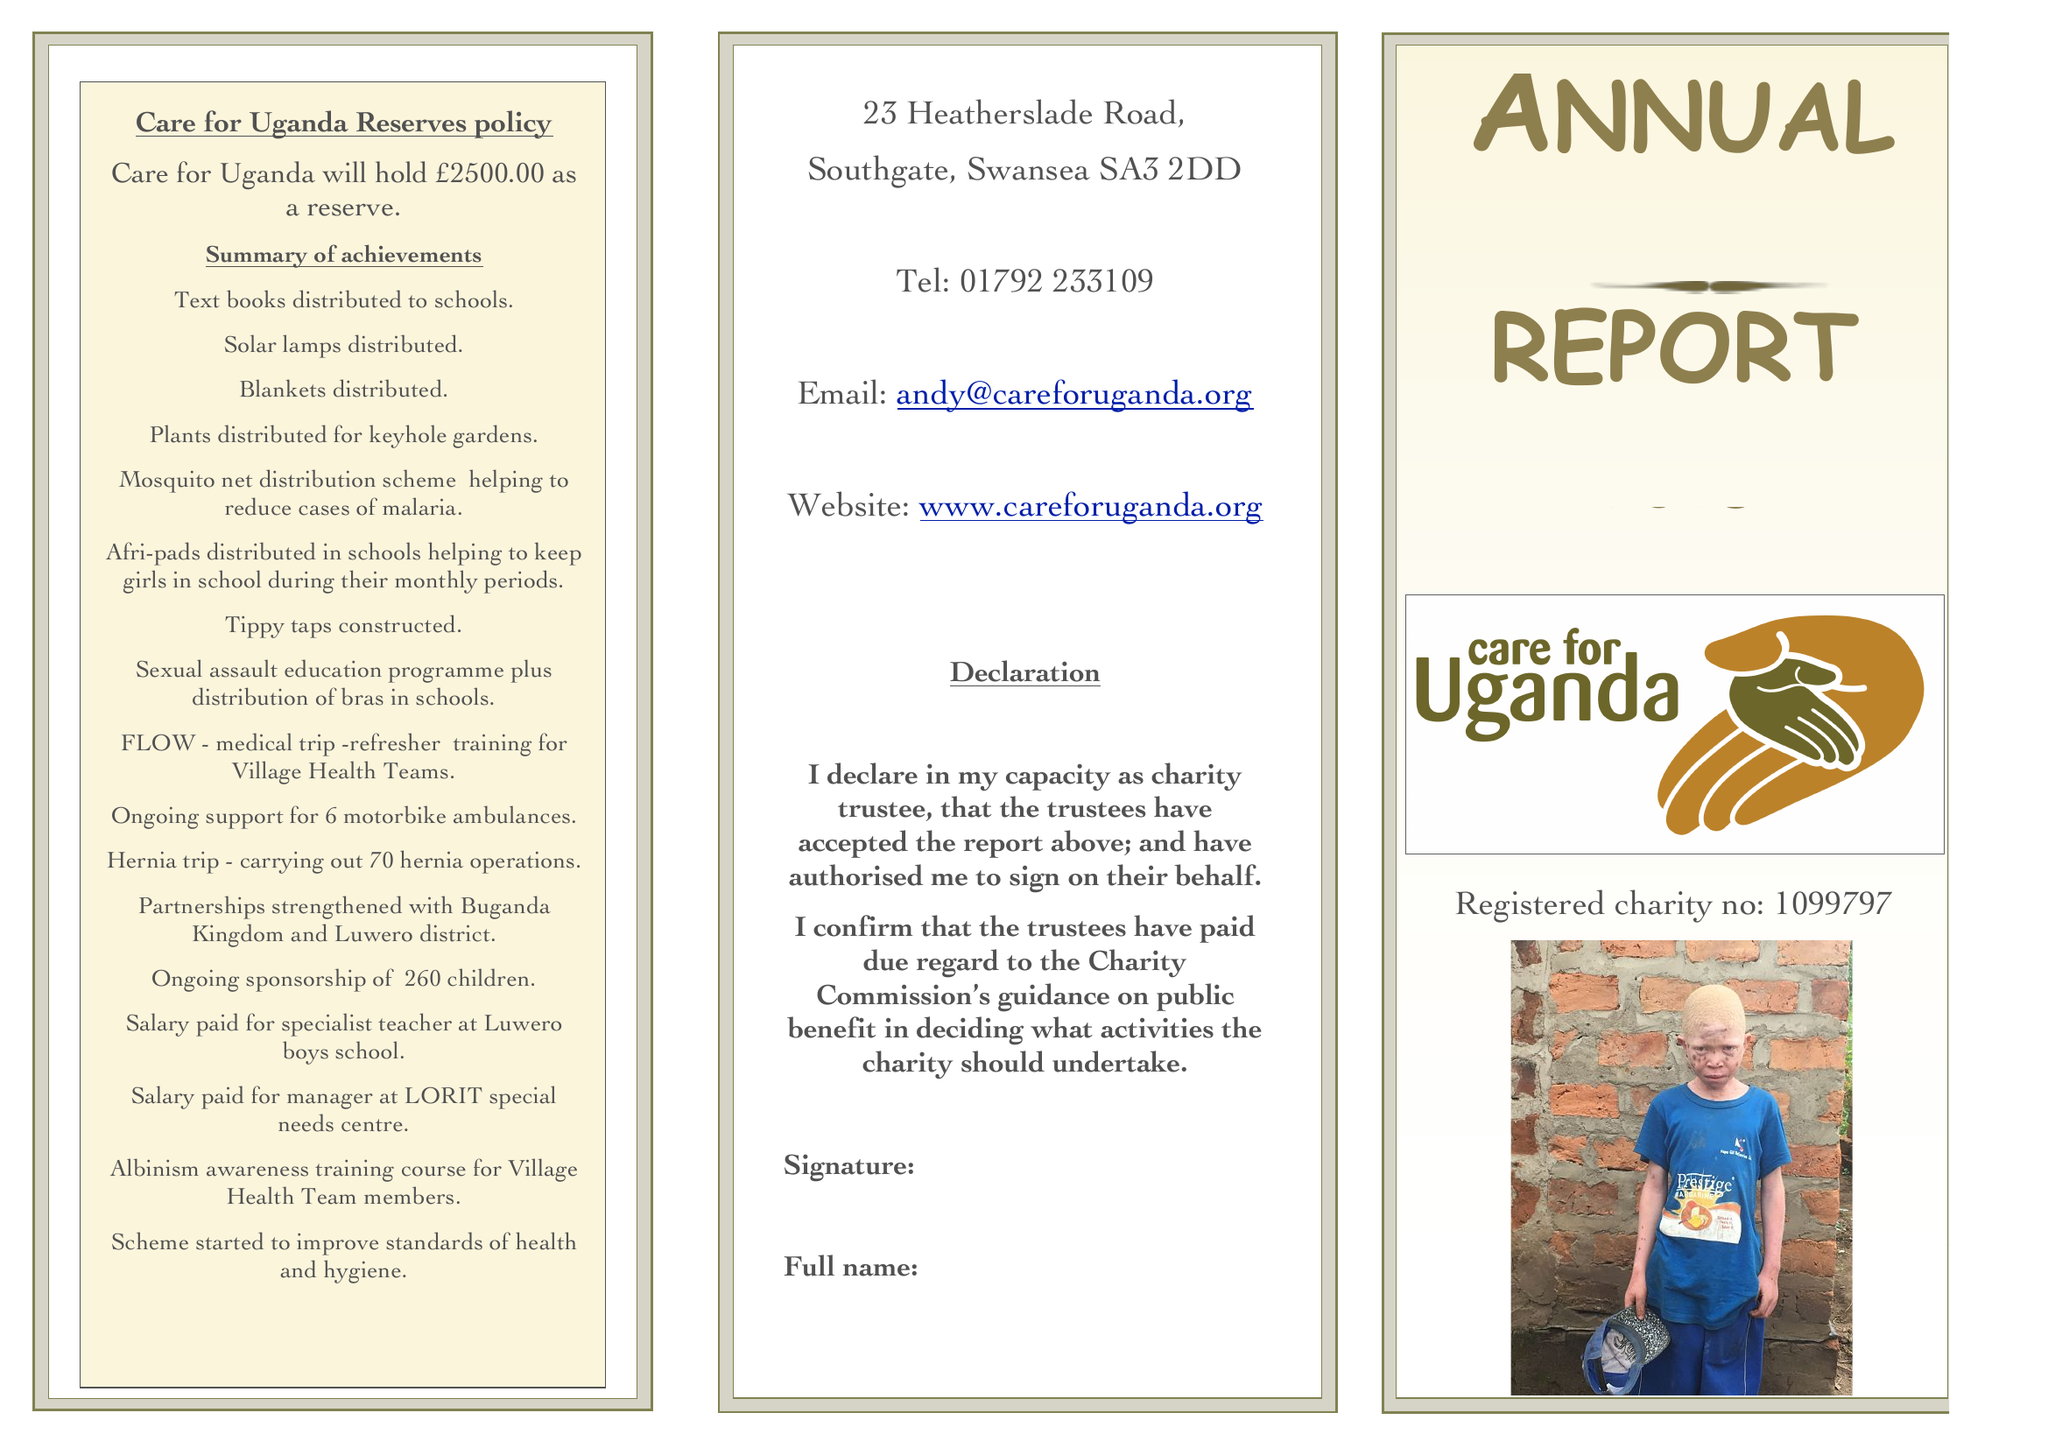What is the value for the charity_number?
Answer the question using a single word or phrase. 1099797 